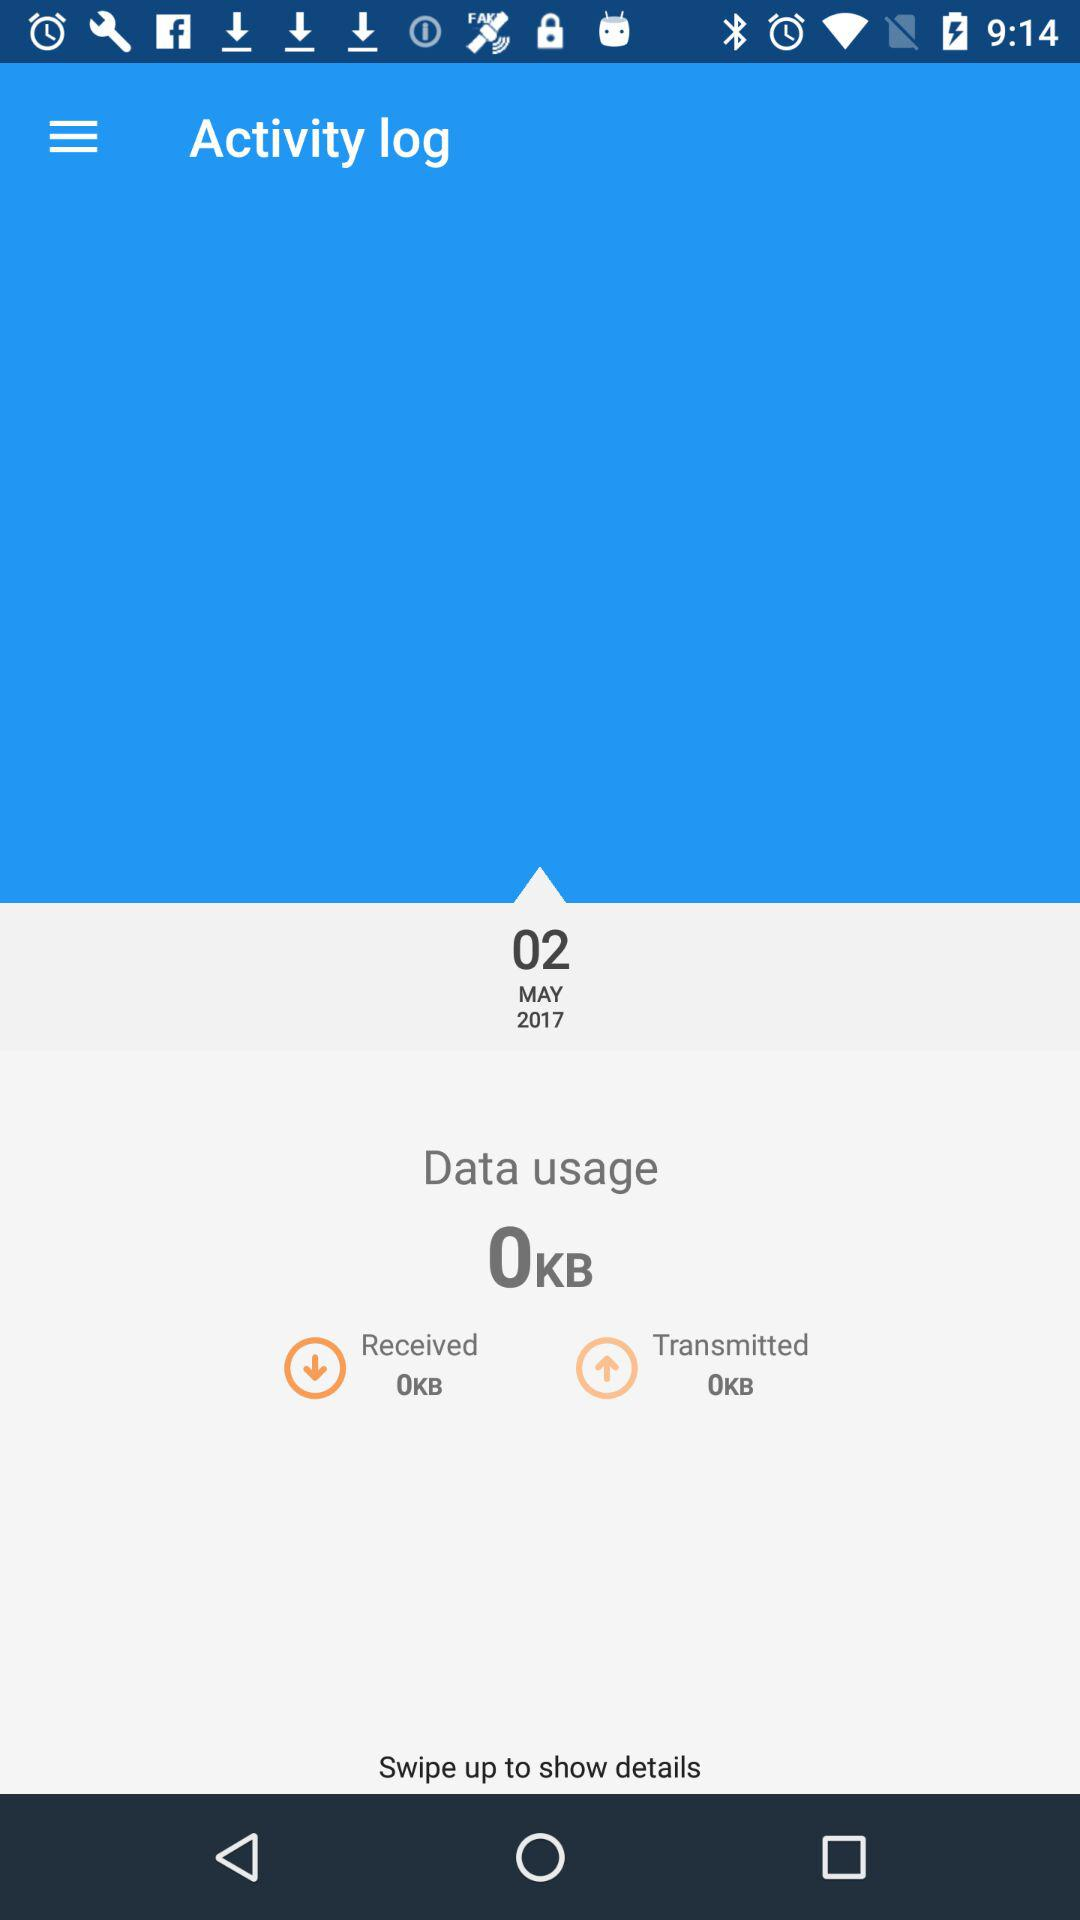What is the date given? The given date is May 02, 2017. 